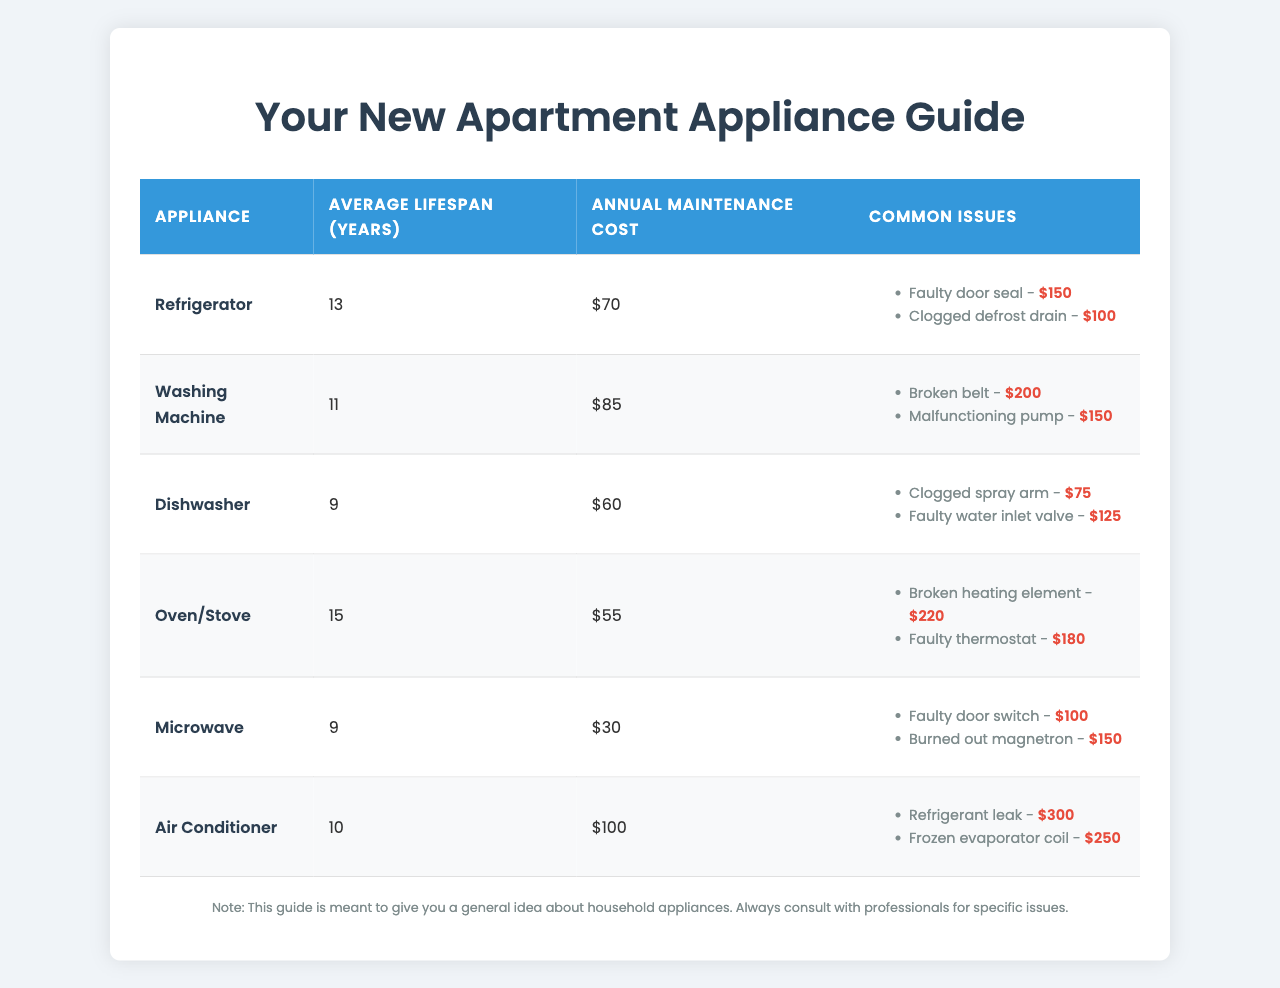What is the average lifespan of a refrigerator? The table states that the average lifespan of a refrigerator is listed under the "Average Lifespan (years)" column for the refrigerator row, which shows "13."
Answer: 13 years Which appliance has the highest annual maintenance cost? Looking at the "Annual Maintenance Cost" column across all appliances, the air conditioner has the highest cost listed as "$100."
Answer: Air Conditioner How much does it cost to repair a broken belt in a washing machine? The common issues for the washing machine indicate that a broken belt has a repair cost of "$200."
Answer: $200 What is the average lifespan of a dishwasher compared to a microwave? The average lifespan for a dishwasher is "9 years," while for a microwave it is also "9 years." Since both are the same, they have an equal lifespan.
Answer: Equal (9 years) What is the total average lifespan of all the appliances listed? Adding the average lifespans gives: 13 + 11 + 9 + 15 + 9 + 10 = 67. The total sum is then divided by the number of appliances (6) for an average of 67/6 ≈ 11.17 years.
Answer: ≈ 11.17 years Is it true that the average maintenance cost for an oven/stove is lower than that of a washing machine? Comparing the annual maintenance costs, an oven/stove has a cost of "$55" which is indeed lower than the washing machine's "$85."
Answer: Yes What common issue in air conditioners has the highest repair cost? Among the listed common issues for air conditioners, a refrigerant leak has a repair cost of "$300," which is higher than the "$250" for a frozen evaporator coil.
Answer: Refrigerant leak ($300) How many more years does the oven/stove last on average compared to the dishwasher? The average lifespan of an oven/stove is "15 years" and the dishwasher is "9 years," so the difference is 15 - 9 = 6 years.
Answer: 6 years Which appliance has the lowest annual maintenance cost, and what is that cost? Reviewing the annual maintenance costs, the microwave lists the lowest at "$30."
Answer: Microwave ($30) If all appliances were to experience all their common issues at least once, what would be the total repair cost for the washing machine? The total repair costs for the common issues in the washing machine are: Broken belt ($200) + Malfunctioning pump ($150) = $350.
Answer: $350 